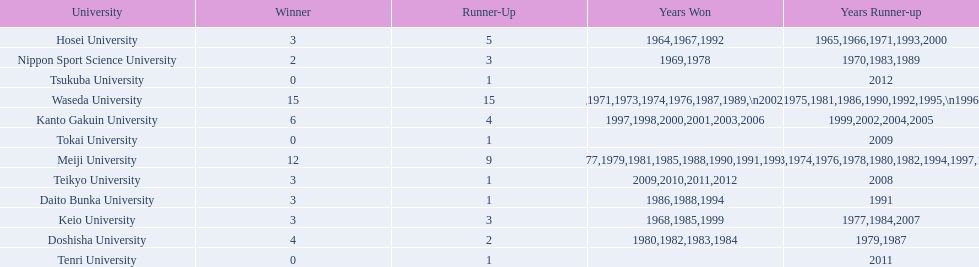What university were there in the all-japan university rugby championship? Waseda University, Meiji University, Kanto Gakuin University, Doshisha University, Hosei University, Keio University, Daito Bunka University, Nippon Sport Science University, Teikyo University, Tokai University, Tenri University, Tsukuba University. Of these who had more than 12 wins? Waseda University. 